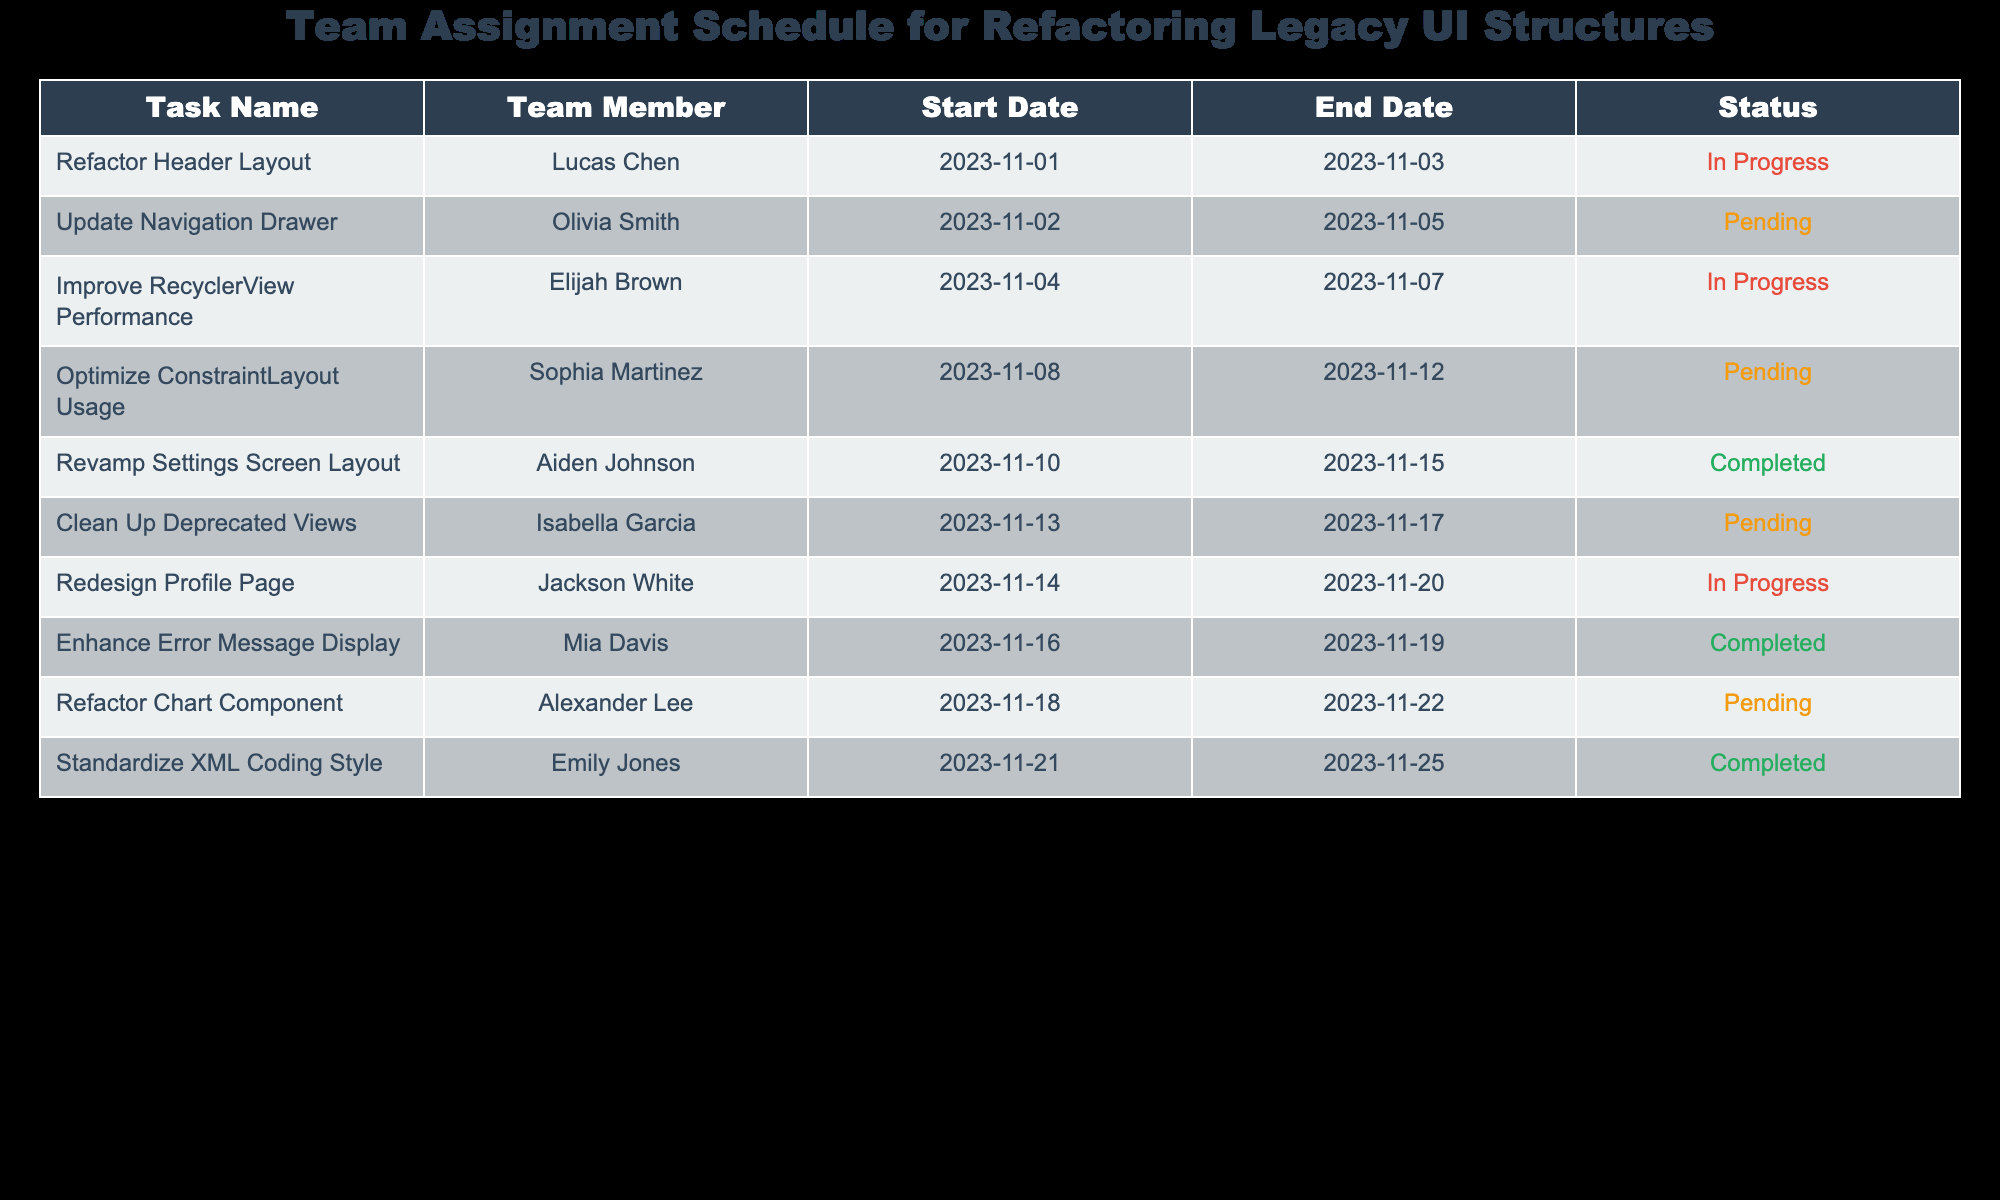What is the task assigned to Lucas Chen? The table shows that Lucas Chen is assigned to the task named "Refactor Header Layout."
Answer: Refactor Header Layout How many tasks are currently in progress? By reviewing the "Status" column, I can see that there are three tasks marked as "In Progress": "Refactor Header Layout," "Improve RecyclerView Performance," and "Redesign Profile Page."
Answer: 3 What are the start and end dates for the task "Standardize XML Coding Style"? For the task "Standardize XML Coding Style," the table indicates a start date of "2023-11-21" and an end date of "2023-11-25."
Answer: Start: 2023-11-21, End: 2023-11-25 Is the task "Clean Up Deprecated Views" currently completed? Looking at the "Status" column for the "Clean Up Deprecated Views" task, it is marked as "Pending," which means it is not completed.
Answer: No What is the average duration of tasks currently marked as "Completed"? The completed tasks are "Revamp Settings Screen Layout," "Enhance Error Message Display," and "Standardize XML Coding Style." Their durations are: 6 days, 3 days, and 5 days respectively. Adding these gives 14 days, and dividing by 3 gives an average of 4.67 days.
Answer: 4.67 days Which team member is responsible for optimizing ConstraintLayout usage? The table shows that Sophia Martinez is assigned to the task "Optimize ConstraintLayout Usage."
Answer: Sophia Martinez How many team members are assigned to tasks with a status of "Pending"? The table lists five tasks with the status "Pending": "Update Navigation Drawer," "Optimize ConstraintLayout Usage," "Clean Up Deprecated Views," and "Refactor Chart Component." Thus, there are four tasks pending and this correlates to four team members assigned.
Answer: 4 Which task has the longest duration? Checking the duration of each task, "Revamp Settings Screen Layout" lasts from 2023-11-10 to 2023-11-15, which is 5 days, but "Refactor Chart Component" lasts from 2023-11-18 to 2023-11-22, which is 4 days. Therefore, the "Revamp Settings Screen Layout" has the longest duration among the completed tasks.
Answer: Revamp Settings Screen Layout Is there any task that starts on November 16, 2023? By checking the "Start Date" column, I see that there is a task titled "Enhance Error Message Display" that starts on November 16, 2023.
Answer: Yes 